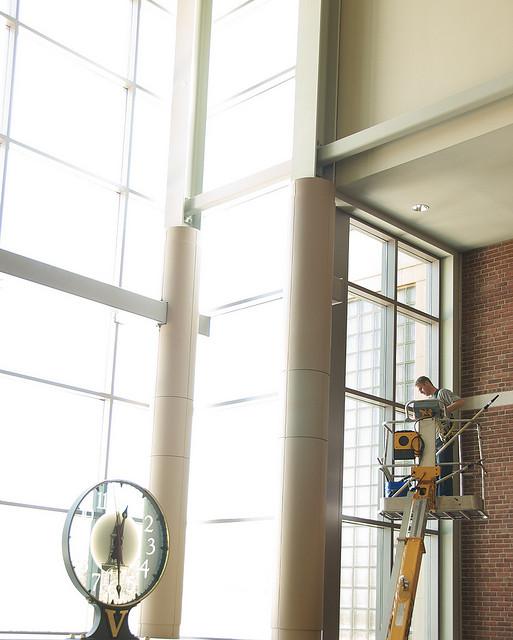What time is it on the clock?
Be succinct. 12:30. What is the man in the lift doing?
Short answer required. Cleaning windows. Where is the clock?
Be succinct. Table. Is the clock transparent?
Keep it brief. Yes. 